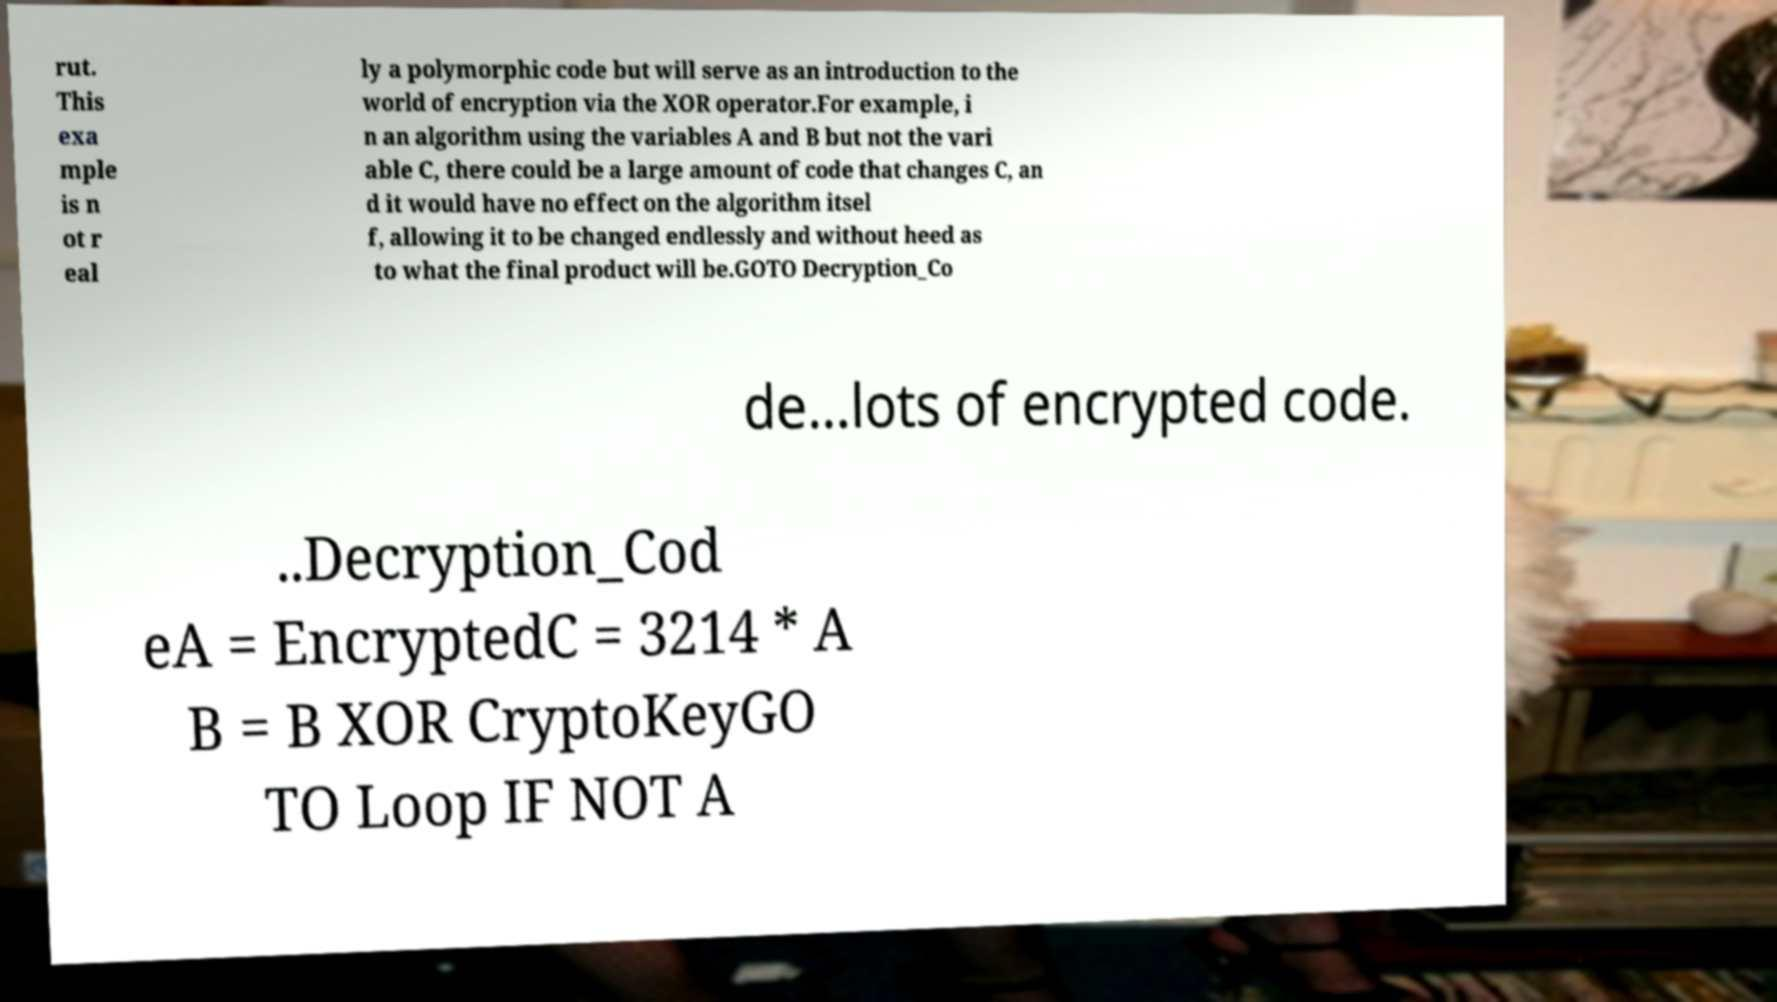Please identify and transcribe the text found in this image. rut. This exa mple is n ot r eal ly a polymorphic code but will serve as an introduction to the world of encryption via the XOR operator.For example, i n an algorithm using the variables A and B but not the vari able C, there could be a large amount of code that changes C, an d it would have no effect on the algorithm itsel f, allowing it to be changed endlessly and without heed as to what the final product will be.GOTO Decryption_Co de...lots of encrypted code. ..Decryption_Cod eA = EncryptedC = 3214 * A B = B XOR CryptoKeyGO TO Loop IF NOT A 